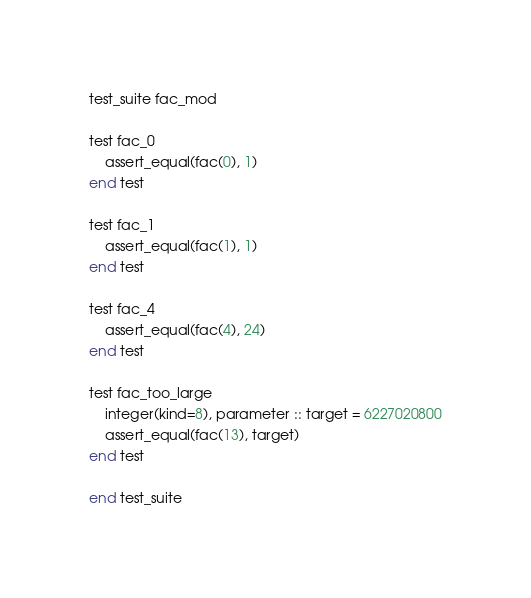Convert code to text. <code><loc_0><loc_0><loc_500><loc_500><_SML_>test_suite fac_mod

test fac_0
    assert_equal(fac(0), 1)
end test

test fac_1
    assert_equal(fac(1), 1)
end test

test fac_4
    assert_equal(fac(4), 24)
end test

test fac_too_large
    integer(kind=8), parameter :: target = 6227020800
    assert_equal(fac(13), target)
end test

end test_suite
</code> 